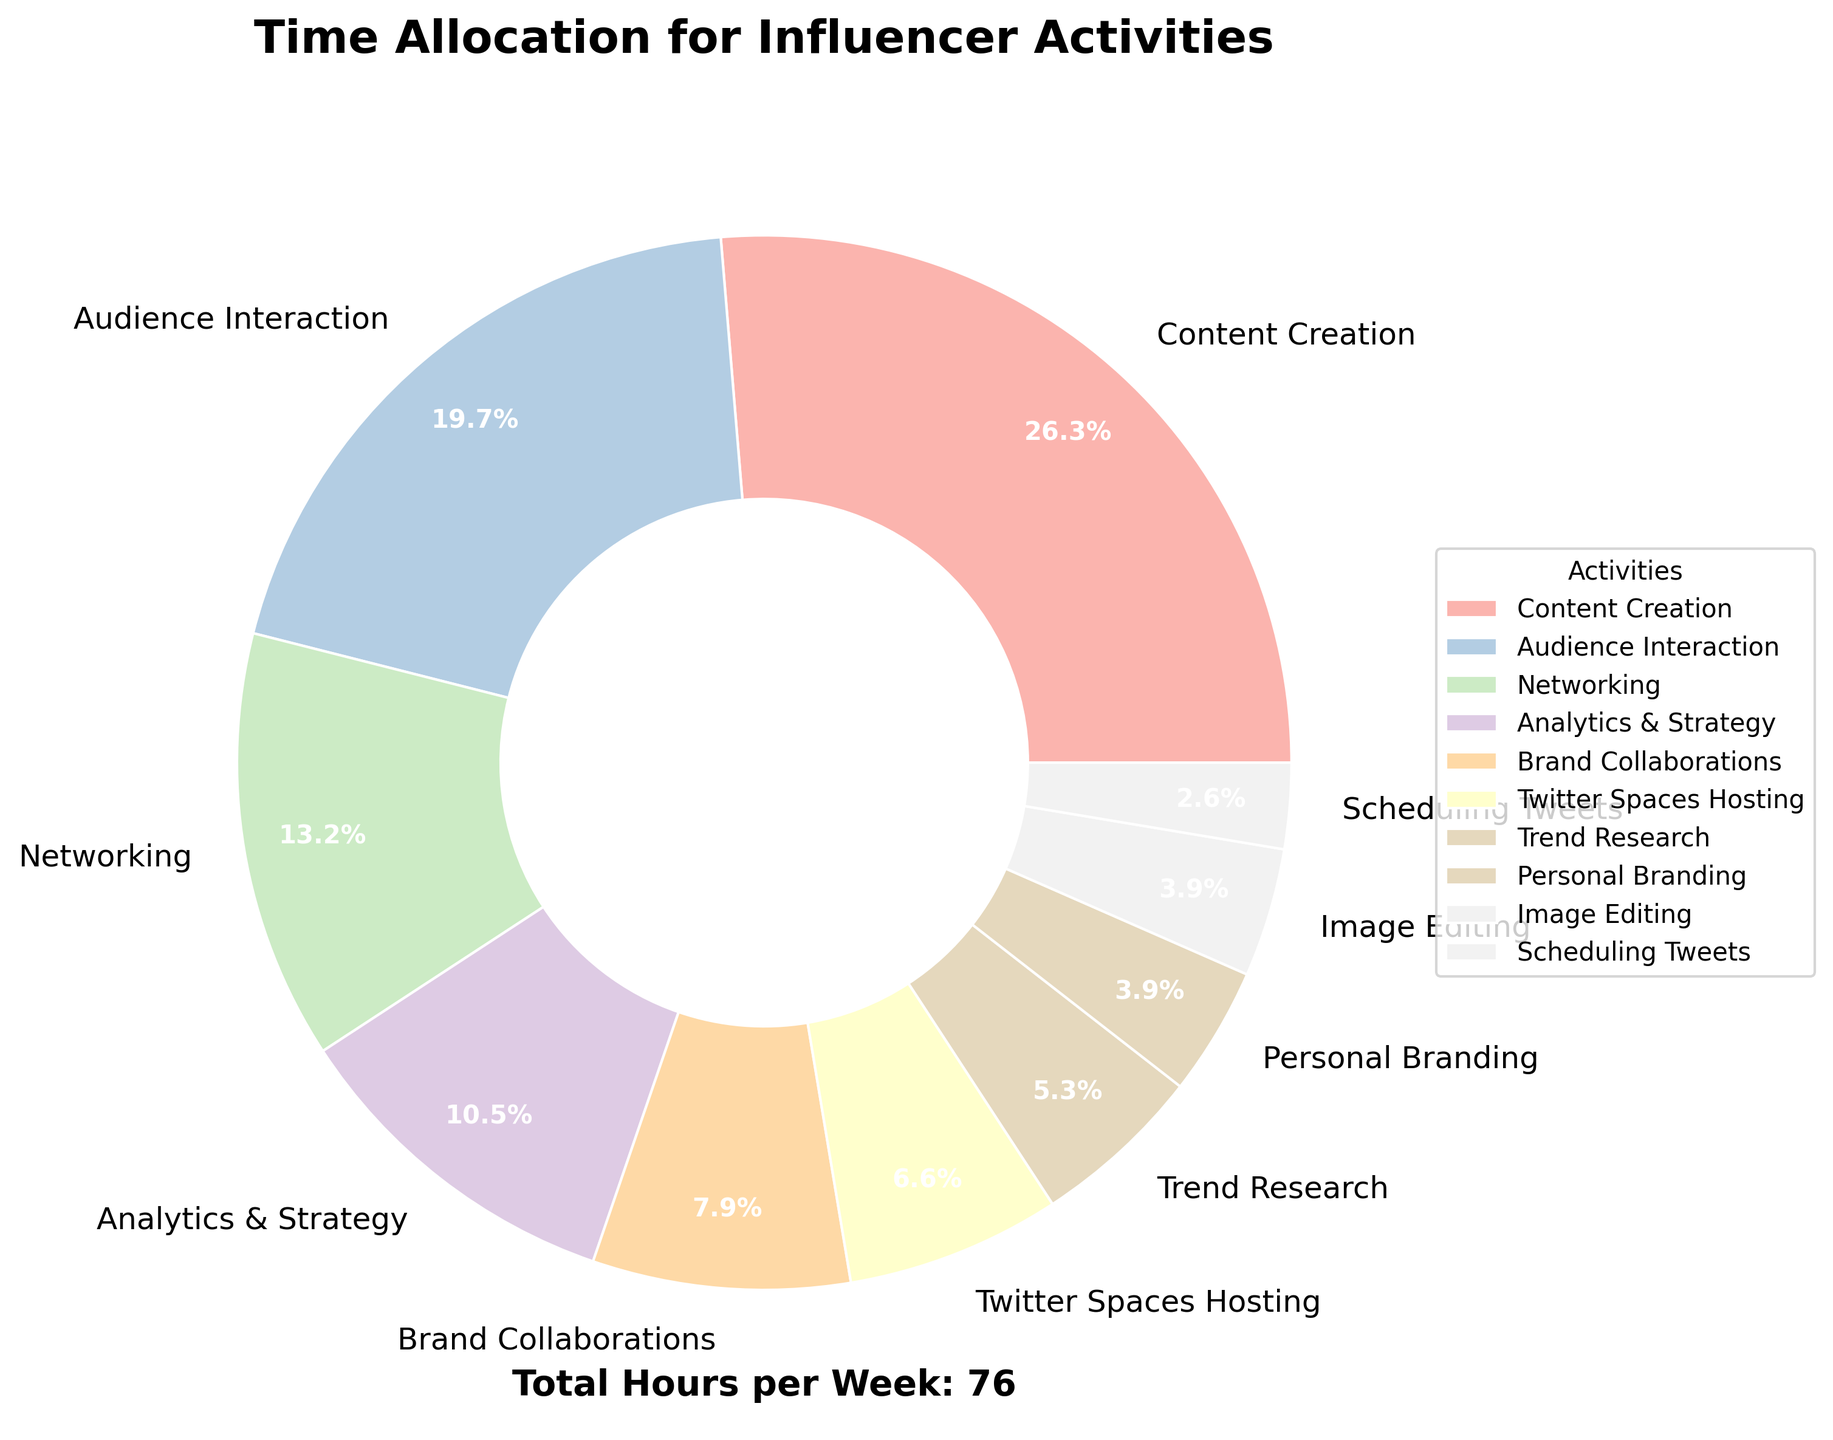What activity takes up the most amount of time per week? The pie chart shows “Content Creation” takes up the largest segment. This segment represents 20 hours per week, which is the highest value among all activities.
Answer: Content Creation How many hours per week are spent on Analytics & Strategy compared to Brand Collaborations? The pie chart shows that "Analytics & Strategy" takes 8 hours per week, while "Brand Collaborations" takes 6 hours per week. To compare, Analytics & Strategy is greater than Brand Collaborations by 8 - 6 = 2 hours.
Answer: 2 hours What is the total time spent on personal branding and image editing together? The pie chart shows that time spent on "Personal Branding" is 3 hours per week, and time spent on "Image Editing" is also 3 hours per week. Adding these together, 3 + 3 = 6 hours.
Answer: 6 hours Is the time spent on Networking more than Audience Interaction? The pie chart shows "Networking" taking up 10 hours per week and "Audience Interaction" taking 15 hours per week. Therefore, Networking is less than Audience Interaction.
Answer: No, less Which activity has the smallest allocation of time? The pie chart reveals the smallest segment is for "Scheduling Tweets,” which takes up 2 hours per week.
Answer: Scheduling Tweets What is the combined time allocated for Networking, Trend Research, and Scheduling Tweets? The pie chart shows times as: Networking (10 hours), Trend Research (4 hours), Scheduling Tweets (2 hours). Summing these, 10 + 4 + 2 = 16 hours.
Answer: 16 hours What percentage of the time is spent on Brand Collaborations? The pie chart shows that the segment for "Brand Collaborations" indicates it takes up 6 hours per week out of a total of 76 hours. Calculating the percentage, (6/76) * 100 ≈ 7.9%.
Answer: 7.9% Which takes more time, Twitter Spaces Hosting or Analytics & Strategy? How many hours more? "Twitter Spaces Hosting" is allocated 5 hours, and "Analytics & Strategy" is allocated 8 hours per week. Therefore, Analytics & Strategy takes more time. The difference is 8 - 5 = 3 hours.
Answer: Analytics & Strategy, 3 hours How many times more hours are spent on Audience Interaction than Scheduling Tweets? The pie chart shows Audience Interaction is allocated 15 hours, and Scheduling Tweets takes 2 hours per week. The ratio is 15 / 2 = 7.5 times more.
Answer: 7.5 times 